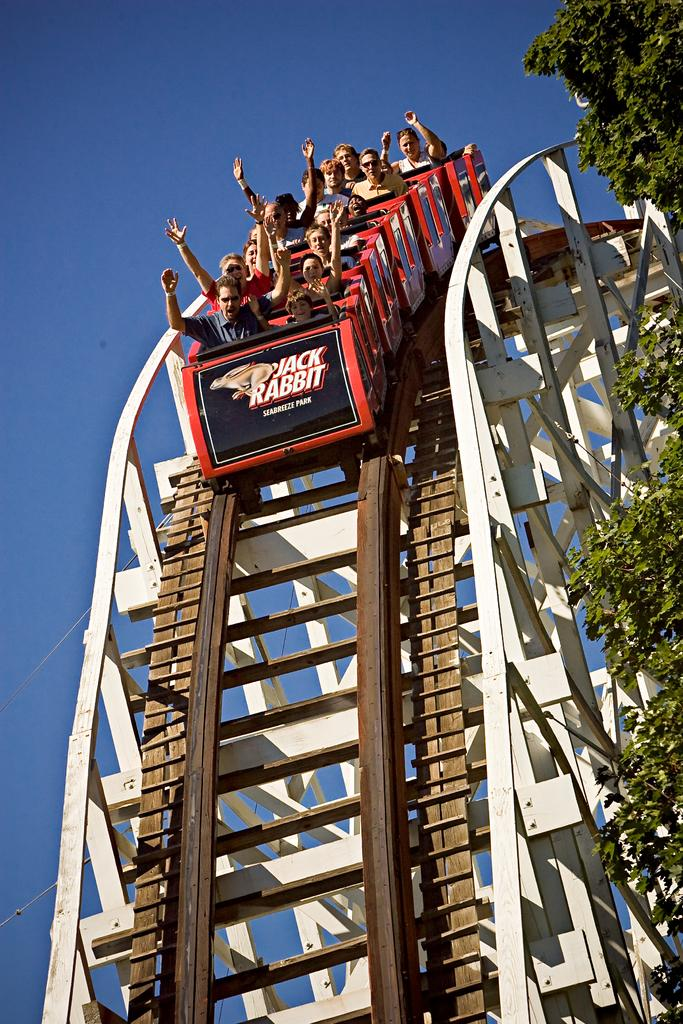What are the people in the image doing? The people are in a roller coaster. What can be seen on the right side of the image? There are trees on the right side of the image. Where is the scarecrow located in the image? There is no scarecrow present in the image. What type of truck can be seen in the image? There is no truck present in the image. 